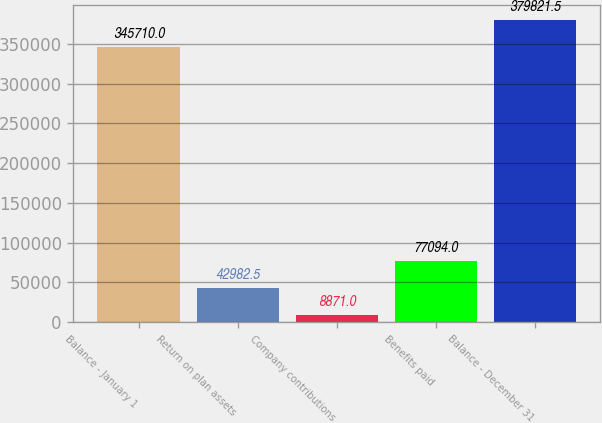Convert chart. <chart><loc_0><loc_0><loc_500><loc_500><bar_chart><fcel>Balance - January 1<fcel>Return on plan assets<fcel>Company contributions<fcel>Benefits paid<fcel>Balance - December 31<nl><fcel>345710<fcel>42982.5<fcel>8871<fcel>77094<fcel>379822<nl></chart> 